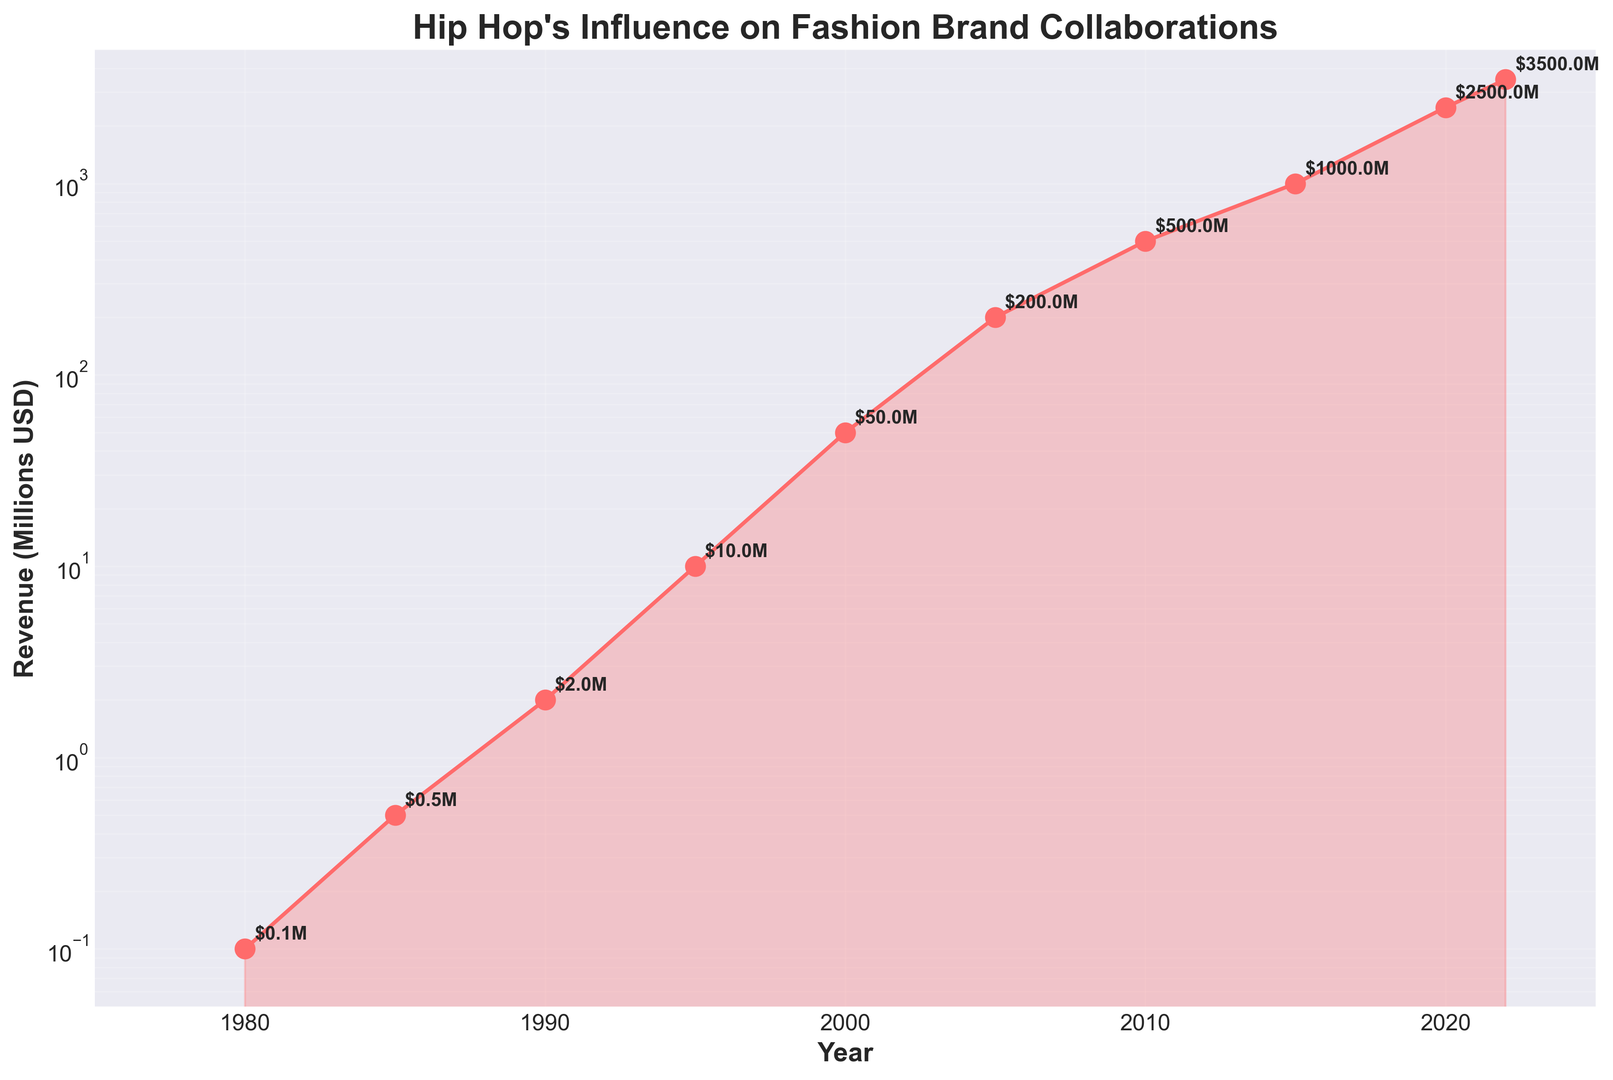What has been the general trend in Hip Hop's influence on fashion brand collaborations from 1980 to 2022? The revenue from fashion brand collaborations influenced by Hip Hop has increased consistently over the years, moving from $0.1 million in 1980 to $3500 million by 2022. This indicates a strong upward trend.
Answer: An increasing trend Which year shows the highest revenue from Hip Hop's influence on fashion brand collaborations? The year 2022 shows the highest revenue from Hip Hop's influence on fashion brand collaborations with $3500 million.
Answer: 2022 By how much did the revenue increase from 2000 to 2022? In 2000, the revenue was $50 million, and in 2022 it was $3500 million. The increase in revenue is $3500 million - $50 million = $3450 million.
Answer: $3450 million Between which consecutive 5-year periods did the revenue see the largest increase? By inspecting the data, the increase between 2000 ($50 million) and 2005 ($200 million) was $150 million, between 2005 and 2010 ($500 million) was $300 million, and between 2015 ($1000 million) and 2020 ($2500 million) was $1500 million. Therefore, the largest increase was between 2015 and 2020.
Answer: 2015-2020 What is the average revenue from 1980 to 2022? To find the average revenue, add up all the revenue values ($0.1M + $0.5M + $2M + $10M + $50M + $200M + $500M + $1000M + $2500M + $3500M) = $7762.6 million. Then divide by the number of years (10): $7762.6 million / 10 = $776.26 million.
Answer: $776.26 million How does the revenue in 1990 compare to the revenue in 1980? In 1990, the revenue is $2 million, and in 1980, it's $0.1 million. Therefore, the revenue in 1990 is significantly higher than in 1980.
Answer: Higher What color is used to represent the data points and fill in the chart? The chart uses red color (specifically a shade similar to red) for both the data points (markers) and the fill between the data points.
Answer: Red What can you infer about the rate of growth in the last two decades compared to the first two decades? The revenue in the last two decades (2000-2022) increased from $50 million to $3500 million, showing a massive growth, while in the first two decades (1980-2000), it went from $0.1 million to $50 million. This indicates that the rate of growth has been significantly higher in the last two decades.
Answer: Higher growth rate in the last two decades How much revenue was generated in the year 2005? The chart indicates that the revenue generated in the year 2005 was $200 million.
Answer: $200 million 